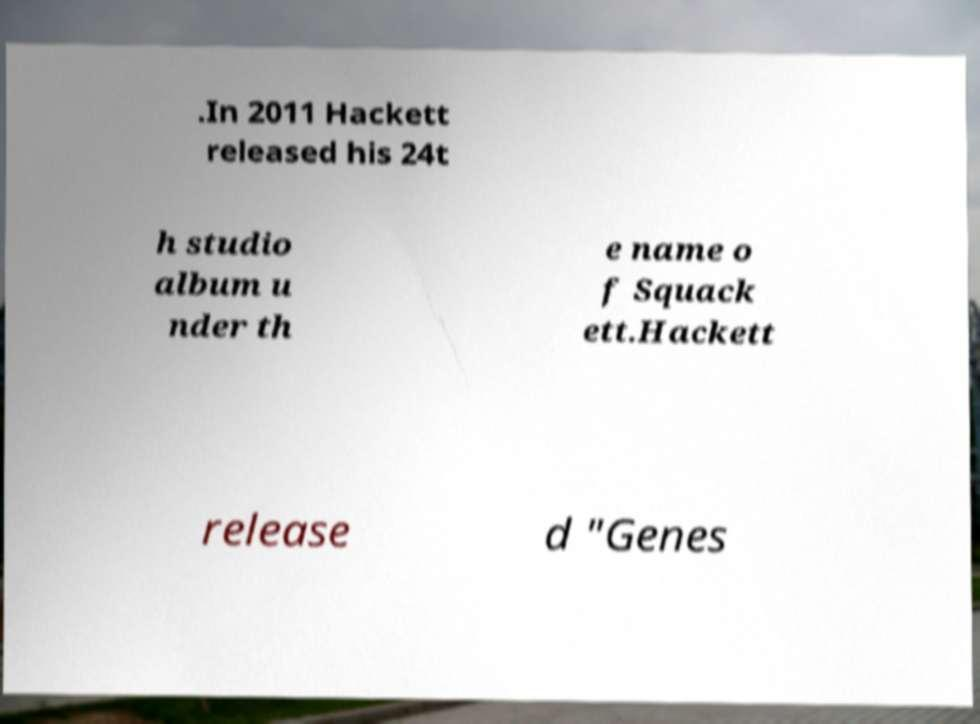Please identify and transcribe the text found in this image. .In 2011 Hackett released his 24t h studio album u nder th e name o f Squack ett.Hackett release d "Genes 